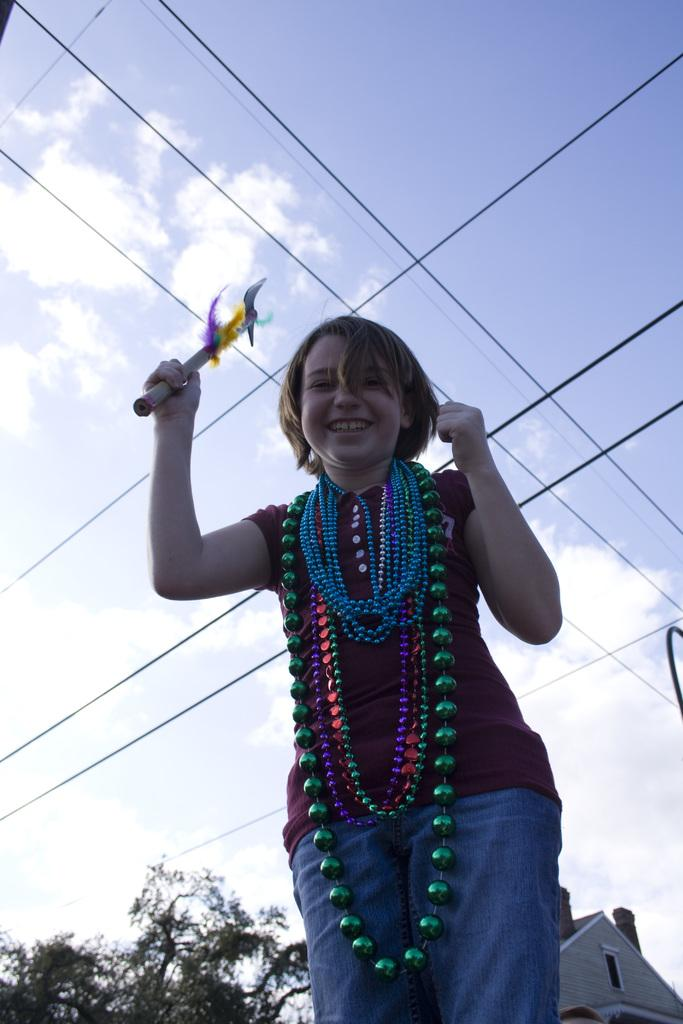What is the person in the image doing? The person is standing in the image and holding a hand fan. What object is the person using in the image? The person is using a hand fan in the image. What can be seen in the background of the image? There are wires, a tree, a building, and the sky visible in the background of the image. What type of crack can be seen on the egg in the image? There is no egg present in the image, so there cannot be any cracks on an egg. 